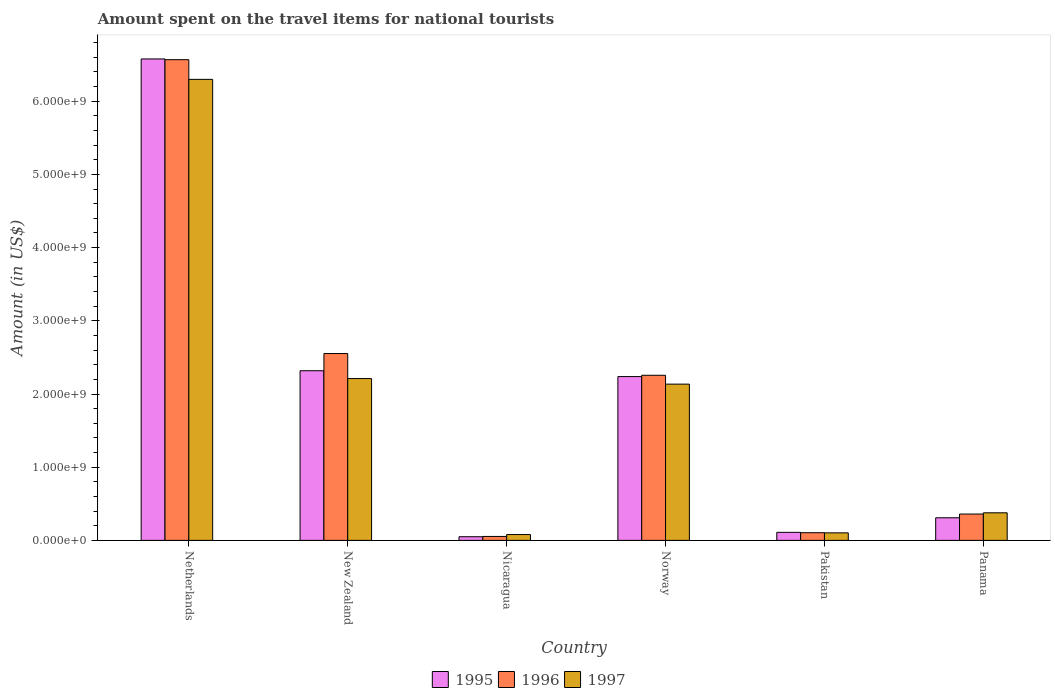Are the number of bars per tick equal to the number of legend labels?
Your answer should be compact. Yes. Are the number of bars on each tick of the X-axis equal?
Your answer should be very brief. Yes. What is the label of the 3rd group of bars from the left?
Provide a succinct answer. Nicaragua. What is the amount spent on the travel items for national tourists in 1995 in Nicaragua?
Provide a short and direct response. 5.00e+07. Across all countries, what is the maximum amount spent on the travel items for national tourists in 1997?
Offer a terse response. 6.30e+09. Across all countries, what is the minimum amount spent on the travel items for national tourists in 1995?
Make the answer very short. 5.00e+07. In which country was the amount spent on the travel items for national tourists in 1997 minimum?
Provide a short and direct response. Nicaragua. What is the total amount spent on the travel items for national tourists in 1996 in the graph?
Your response must be concise. 1.19e+1. What is the difference between the amount spent on the travel items for national tourists in 1996 in Nicaragua and that in Panama?
Make the answer very short. -3.06e+08. What is the difference between the amount spent on the travel items for national tourists in 1997 in Nicaragua and the amount spent on the travel items for national tourists in 1996 in Pakistan?
Ensure brevity in your answer.  -2.50e+07. What is the average amount spent on the travel items for national tourists in 1997 per country?
Ensure brevity in your answer.  1.87e+09. What is the difference between the amount spent on the travel items for national tourists of/in 1997 and amount spent on the travel items for national tourists of/in 1995 in New Zealand?
Keep it short and to the point. -1.07e+08. In how many countries, is the amount spent on the travel items for national tourists in 1997 greater than 4200000000 US$?
Offer a terse response. 1. What is the ratio of the amount spent on the travel items for national tourists in 1997 in New Zealand to that in Norway?
Keep it short and to the point. 1.04. Is the amount spent on the travel items for national tourists in 1997 in New Zealand less than that in Norway?
Your answer should be compact. No. Is the difference between the amount spent on the travel items for national tourists in 1997 in New Zealand and Panama greater than the difference between the amount spent on the travel items for national tourists in 1995 in New Zealand and Panama?
Give a very brief answer. No. What is the difference between the highest and the second highest amount spent on the travel items for national tourists in 1997?
Provide a short and direct response. 4.16e+09. What is the difference between the highest and the lowest amount spent on the travel items for national tourists in 1996?
Keep it short and to the point. 6.51e+09. Is it the case that in every country, the sum of the amount spent on the travel items for national tourists in 1996 and amount spent on the travel items for national tourists in 1995 is greater than the amount spent on the travel items for national tourists in 1997?
Make the answer very short. Yes. How many bars are there?
Your answer should be compact. 18. Are all the bars in the graph horizontal?
Provide a succinct answer. No. How many countries are there in the graph?
Offer a very short reply. 6. What is the difference between two consecutive major ticks on the Y-axis?
Keep it short and to the point. 1.00e+09. Where does the legend appear in the graph?
Offer a very short reply. Bottom center. How many legend labels are there?
Provide a succinct answer. 3. How are the legend labels stacked?
Offer a terse response. Horizontal. What is the title of the graph?
Make the answer very short. Amount spent on the travel items for national tourists. What is the Amount (in US$) in 1995 in Netherlands?
Your response must be concise. 6.58e+09. What is the Amount (in US$) in 1996 in Netherlands?
Keep it short and to the point. 6.57e+09. What is the Amount (in US$) of 1997 in Netherlands?
Provide a short and direct response. 6.30e+09. What is the Amount (in US$) of 1995 in New Zealand?
Provide a succinct answer. 2.32e+09. What is the Amount (in US$) in 1996 in New Zealand?
Ensure brevity in your answer.  2.55e+09. What is the Amount (in US$) in 1997 in New Zealand?
Keep it short and to the point. 2.21e+09. What is the Amount (in US$) of 1996 in Nicaragua?
Your response must be concise. 5.40e+07. What is the Amount (in US$) of 1997 in Nicaragua?
Ensure brevity in your answer.  8.00e+07. What is the Amount (in US$) of 1995 in Norway?
Your answer should be very brief. 2.24e+09. What is the Amount (in US$) of 1996 in Norway?
Offer a very short reply. 2.26e+09. What is the Amount (in US$) of 1997 in Norway?
Your answer should be very brief. 2.14e+09. What is the Amount (in US$) of 1995 in Pakistan?
Make the answer very short. 1.10e+08. What is the Amount (in US$) of 1996 in Pakistan?
Keep it short and to the point. 1.05e+08. What is the Amount (in US$) in 1997 in Pakistan?
Ensure brevity in your answer.  1.03e+08. What is the Amount (in US$) of 1995 in Panama?
Offer a terse response. 3.09e+08. What is the Amount (in US$) in 1996 in Panama?
Your answer should be very brief. 3.60e+08. What is the Amount (in US$) in 1997 in Panama?
Provide a succinct answer. 3.77e+08. Across all countries, what is the maximum Amount (in US$) of 1995?
Ensure brevity in your answer.  6.58e+09. Across all countries, what is the maximum Amount (in US$) of 1996?
Offer a very short reply. 6.57e+09. Across all countries, what is the maximum Amount (in US$) in 1997?
Provide a succinct answer. 6.30e+09. Across all countries, what is the minimum Amount (in US$) of 1995?
Offer a very short reply. 5.00e+07. Across all countries, what is the minimum Amount (in US$) of 1996?
Provide a short and direct response. 5.40e+07. Across all countries, what is the minimum Amount (in US$) in 1997?
Give a very brief answer. 8.00e+07. What is the total Amount (in US$) in 1995 in the graph?
Your answer should be compact. 1.16e+1. What is the total Amount (in US$) of 1996 in the graph?
Provide a short and direct response. 1.19e+1. What is the total Amount (in US$) of 1997 in the graph?
Give a very brief answer. 1.12e+1. What is the difference between the Amount (in US$) in 1995 in Netherlands and that in New Zealand?
Your answer should be very brief. 4.26e+09. What is the difference between the Amount (in US$) of 1996 in Netherlands and that in New Zealand?
Make the answer very short. 4.02e+09. What is the difference between the Amount (in US$) of 1997 in Netherlands and that in New Zealand?
Provide a short and direct response. 4.09e+09. What is the difference between the Amount (in US$) in 1995 in Netherlands and that in Nicaragua?
Make the answer very short. 6.53e+09. What is the difference between the Amount (in US$) of 1996 in Netherlands and that in Nicaragua?
Offer a terse response. 6.51e+09. What is the difference between the Amount (in US$) of 1997 in Netherlands and that in Nicaragua?
Offer a very short reply. 6.22e+09. What is the difference between the Amount (in US$) of 1995 in Netherlands and that in Norway?
Your answer should be very brief. 4.34e+09. What is the difference between the Amount (in US$) in 1996 in Netherlands and that in Norway?
Provide a short and direct response. 4.31e+09. What is the difference between the Amount (in US$) of 1997 in Netherlands and that in Norway?
Keep it short and to the point. 4.16e+09. What is the difference between the Amount (in US$) in 1995 in Netherlands and that in Pakistan?
Your answer should be compact. 6.47e+09. What is the difference between the Amount (in US$) of 1996 in Netherlands and that in Pakistan?
Give a very brief answer. 6.46e+09. What is the difference between the Amount (in US$) of 1997 in Netherlands and that in Pakistan?
Ensure brevity in your answer.  6.20e+09. What is the difference between the Amount (in US$) of 1995 in Netherlands and that in Panama?
Your response must be concise. 6.27e+09. What is the difference between the Amount (in US$) in 1996 in Netherlands and that in Panama?
Keep it short and to the point. 6.21e+09. What is the difference between the Amount (in US$) in 1997 in Netherlands and that in Panama?
Give a very brief answer. 5.92e+09. What is the difference between the Amount (in US$) in 1995 in New Zealand and that in Nicaragua?
Offer a terse response. 2.27e+09. What is the difference between the Amount (in US$) in 1996 in New Zealand and that in Nicaragua?
Provide a succinct answer. 2.50e+09. What is the difference between the Amount (in US$) of 1997 in New Zealand and that in Nicaragua?
Your answer should be very brief. 2.13e+09. What is the difference between the Amount (in US$) in 1995 in New Zealand and that in Norway?
Offer a terse response. 8.00e+07. What is the difference between the Amount (in US$) of 1996 in New Zealand and that in Norway?
Make the answer very short. 2.97e+08. What is the difference between the Amount (in US$) of 1997 in New Zealand and that in Norway?
Offer a very short reply. 7.60e+07. What is the difference between the Amount (in US$) in 1995 in New Zealand and that in Pakistan?
Make the answer very short. 2.21e+09. What is the difference between the Amount (in US$) of 1996 in New Zealand and that in Pakistan?
Provide a short and direct response. 2.45e+09. What is the difference between the Amount (in US$) of 1997 in New Zealand and that in Pakistan?
Offer a terse response. 2.11e+09. What is the difference between the Amount (in US$) in 1995 in New Zealand and that in Panama?
Keep it short and to the point. 2.01e+09. What is the difference between the Amount (in US$) in 1996 in New Zealand and that in Panama?
Provide a short and direct response. 2.19e+09. What is the difference between the Amount (in US$) in 1997 in New Zealand and that in Panama?
Your answer should be very brief. 1.83e+09. What is the difference between the Amount (in US$) of 1995 in Nicaragua and that in Norway?
Offer a very short reply. -2.19e+09. What is the difference between the Amount (in US$) in 1996 in Nicaragua and that in Norway?
Provide a succinct answer. -2.20e+09. What is the difference between the Amount (in US$) in 1997 in Nicaragua and that in Norway?
Your answer should be very brief. -2.06e+09. What is the difference between the Amount (in US$) of 1995 in Nicaragua and that in Pakistan?
Provide a short and direct response. -6.00e+07. What is the difference between the Amount (in US$) of 1996 in Nicaragua and that in Pakistan?
Keep it short and to the point. -5.10e+07. What is the difference between the Amount (in US$) in 1997 in Nicaragua and that in Pakistan?
Offer a very short reply. -2.30e+07. What is the difference between the Amount (in US$) in 1995 in Nicaragua and that in Panama?
Ensure brevity in your answer.  -2.59e+08. What is the difference between the Amount (in US$) of 1996 in Nicaragua and that in Panama?
Provide a short and direct response. -3.06e+08. What is the difference between the Amount (in US$) of 1997 in Nicaragua and that in Panama?
Offer a very short reply. -2.97e+08. What is the difference between the Amount (in US$) in 1995 in Norway and that in Pakistan?
Offer a terse response. 2.13e+09. What is the difference between the Amount (in US$) of 1996 in Norway and that in Pakistan?
Keep it short and to the point. 2.15e+09. What is the difference between the Amount (in US$) in 1997 in Norway and that in Pakistan?
Make the answer very short. 2.03e+09. What is the difference between the Amount (in US$) of 1995 in Norway and that in Panama?
Your answer should be very brief. 1.93e+09. What is the difference between the Amount (in US$) of 1996 in Norway and that in Panama?
Your answer should be very brief. 1.90e+09. What is the difference between the Amount (in US$) in 1997 in Norway and that in Panama?
Your response must be concise. 1.76e+09. What is the difference between the Amount (in US$) in 1995 in Pakistan and that in Panama?
Your answer should be very brief. -1.99e+08. What is the difference between the Amount (in US$) of 1996 in Pakistan and that in Panama?
Make the answer very short. -2.55e+08. What is the difference between the Amount (in US$) of 1997 in Pakistan and that in Panama?
Give a very brief answer. -2.74e+08. What is the difference between the Amount (in US$) in 1995 in Netherlands and the Amount (in US$) in 1996 in New Zealand?
Keep it short and to the point. 4.02e+09. What is the difference between the Amount (in US$) in 1995 in Netherlands and the Amount (in US$) in 1997 in New Zealand?
Your answer should be very brief. 4.37e+09. What is the difference between the Amount (in US$) in 1996 in Netherlands and the Amount (in US$) in 1997 in New Zealand?
Offer a terse response. 4.36e+09. What is the difference between the Amount (in US$) in 1995 in Netherlands and the Amount (in US$) in 1996 in Nicaragua?
Your answer should be compact. 6.52e+09. What is the difference between the Amount (in US$) in 1995 in Netherlands and the Amount (in US$) in 1997 in Nicaragua?
Provide a succinct answer. 6.50e+09. What is the difference between the Amount (in US$) of 1996 in Netherlands and the Amount (in US$) of 1997 in Nicaragua?
Keep it short and to the point. 6.49e+09. What is the difference between the Amount (in US$) of 1995 in Netherlands and the Amount (in US$) of 1996 in Norway?
Offer a terse response. 4.32e+09. What is the difference between the Amount (in US$) of 1995 in Netherlands and the Amount (in US$) of 1997 in Norway?
Your answer should be compact. 4.44e+09. What is the difference between the Amount (in US$) of 1996 in Netherlands and the Amount (in US$) of 1997 in Norway?
Offer a very short reply. 4.43e+09. What is the difference between the Amount (in US$) of 1995 in Netherlands and the Amount (in US$) of 1996 in Pakistan?
Your response must be concise. 6.47e+09. What is the difference between the Amount (in US$) in 1995 in Netherlands and the Amount (in US$) in 1997 in Pakistan?
Ensure brevity in your answer.  6.48e+09. What is the difference between the Amount (in US$) of 1996 in Netherlands and the Amount (in US$) of 1997 in Pakistan?
Ensure brevity in your answer.  6.46e+09. What is the difference between the Amount (in US$) in 1995 in Netherlands and the Amount (in US$) in 1996 in Panama?
Provide a succinct answer. 6.22e+09. What is the difference between the Amount (in US$) of 1995 in Netherlands and the Amount (in US$) of 1997 in Panama?
Offer a very short reply. 6.20e+09. What is the difference between the Amount (in US$) in 1996 in Netherlands and the Amount (in US$) in 1997 in Panama?
Give a very brief answer. 6.19e+09. What is the difference between the Amount (in US$) in 1995 in New Zealand and the Amount (in US$) in 1996 in Nicaragua?
Give a very brief answer. 2.26e+09. What is the difference between the Amount (in US$) in 1995 in New Zealand and the Amount (in US$) in 1997 in Nicaragua?
Your answer should be compact. 2.24e+09. What is the difference between the Amount (in US$) of 1996 in New Zealand and the Amount (in US$) of 1997 in Nicaragua?
Make the answer very short. 2.47e+09. What is the difference between the Amount (in US$) in 1995 in New Zealand and the Amount (in US$) in 1996 in Norway?
Make the answer very short. 6.20e+07. What is the difference between the Amount (in US$) of 1995 in New Zealand and the Amount (in US$) of 1997 in Norway?
Your answer should be compact. 1.83e+08. What is the difference between the Amount (in US$) of 1996 in New Zealand and the Amount (in US$) of 1997 in Norway?
Provide a short and direct response. 4.18e+08. What is the difference between the Amount (in US$) in 1995 in New Zealand and the Amount (in US$) in 1996 in Pakistan?
Offer a terse response. 2.21e+09. What is the difference between the Amount (in US$) in 1995 in New Zealand and the Amount (in US$) in 1997 in Pakistan?
Offer a very short reply. 2.22e+09. What is the difference between the Amount (in US$) in 1996 in New Zealand and the Amount (in US$) in 1997 in Pakistan?
Your response must be concise. 2.45e+09. What is the difference between the Amount (in US$) in 1995 in New Zealand and the Amount (in US$) in 1996 in Panama?
Your response must be concise. 1.96e+09. What is the difference between the Amount (in US$) in 1995 in New Zealand and the Amount (in US$) in 1997 in Panama?
Offer a terse response. 1.94e+09. What is the difference between the Amount (in US$) in 1996 in New Zealand and the Amount (in US$) in 1997 in Panama?
Keep it short and to the point. 2.18e+09. What is the difference between the Amount (in US$) of 1995 in Nicaragua and the Amount (in US$) of 1996 in Norway?
Provide a succinct answer. -2.21e+09. What is the difference between the Amount (in US$) in 1995 in Nicaragua and the Amount (in US$) in 1997 in Norway?
Give a very brief answer. -2.08e+09. What is the difference between the Amount (in US$) in 1996 in Nicaragua and the Amount (in US$) in 1997 in Norway?
Give a very brief answer. -2.08e+09. What is the difference between the Amount (in US$) in 1995 in Nicaragua and the Amount (in US$) in 1996 in Pakistan?
Your response must be concise. -5.50e+07. What is the difference between the Amount (in US$) in 1995 in Nicaragua and the Amount (in US$) in 1997 in Pakistan?
Your answer should be very brief. -5.30e+07. What is the difference between the Amount (in US$) of 1996 in Nicaragua and the Amount (in US$) of 1997 in Pakistan?
Give a very brief answer. -4.90e+07. What is the difference between the Amount (in US$) of 1995 in Nicaragua and the Amount (in US$) of 1996 in Panama?
Your response must be concise. -3.10e+08. What is the difference between the Amount (in US$) of 1995 in Nicaragua and the Amount (in US$) of 1997 in Panama?
Keep it short and to the point. -3.27e+08. What is the difference between the Amount (in US$) in 1996 in Nicaragua and the Amount (in US$) in 1997 in Panama?
Ensure brevity in your answer.  -3.23e+08. What is the difference between the Amount (in US$) in 1995 in Norway and the Amount (in US$) in 1996 in Pakistan?
Your answer should be very brief. 2.13e+09. What is the difference between the Amount (in US$) of 1995 in Norway and the Amount (in US$) of 1997 in Pakistan?
Provide a succinct answer. 2.14e+09. What is the difference between the Amount (in US$) in 1996 in Norway and the Amount (in US$) in 1997 in Pakistan?
Ensure brevity in your answer.  2.15e+09. What is the difference between the Amount (in US$) in 1995 in Norway and the Amount (in US$) in 1996 in Panama?
Provide a short and direct response. 1.88e+09. What is the difference between the Amount (in US$) of 1995 in Norway and the Amount (in US$) of 1997 in Panama?
Your answer should be compact. 1.86e+09. What is the difference between the Amount (in US$) of 1996 in Norway and the Amount (in US$) of 1997 in Panama?
Ensure brevity in your answer.  1.88e+09. What is the difference between the Amount (in US$) of 1995 in Pakistan and the Amount (in US$) of 1996 in Panama?
Your response must be concise. -2.50e+08. What is the difference between the Amount (in US$) of 1995 in Pakistan and the Amount (in US$) of 1997 in Panama?
Your answer should be very brief. -2.67e+08. What is the difference between the Amount (in US$) in 1996 in Pakistan and the Amount (in US$) in 1997 in Panama?
Make the answer very short. -2.72e+08. What is the average Amount (in US$) in 1995 per country?
Provide a succinct answer. 1.93e+09. What is the average Amount (in US$) of 1996 per country?
Make the answer very short. 1.98e+09. What is the average Amount (in US$) in 1997 per country?
Your answer should be compact. 1.87e+09. What is the difference between the Amount (in US$) in 1995 and Amount (in US$) in 1996 in Netherlands?
Give a very brief answer. 1.00e+07. What is the difference between the Amount (in US$) of 1995 and Amount (in US$) of 1997 in Netherlands?
Give a very brief answer. 2.79e+08. What is the difference between the Amount (in US$) of 1996 and Amount (in US$) of 1997 in Netherlands?
Give a very brief answer. 2.69e+08. What is the difference between the Amount (in US$) in 1995 and Amount (in US$) in 1996 in New Zealand?
Ensure brevity in your answer.  -2.35e+08. What is the difference between the Amount (in US$) of 1995 and Amount (in US$) of 1997 in New Zealand?
Your answer should be compact. 1.07e+08. What is the difference between the Amount (in US$) of 1996 and Amount (in US$) of 1997 in New Zealand?
Make the answer very short. 3.42e+08. What is the difference between the Amount (in US$) of 1995 and Amount (in US$) of 1997 in Nicaragua?
Give a very brief answer. -3.00e+07. What is the difference between the Amount (in US$) of 1996 and Amount (in US$) of 1997 in Nicaragua?
Offer a very short reply. -2.60e+07. What is the difference between the Amount (in US$) in 1995 and Amount (in US$) in 1996 in Norway?
Give a very brief answer. -1.80e+07. What is the difference between the Amount (in US$) of 1995 and Amount (in US$) of 1997 in Norway?
Provide a short and direct response. 1.03e+08. What is the difference between the Amount (in US$) of 1996 and Amount (in US$) of 1997 in Norway?
Ensure brevity in your answer.  1.21e+08. What is the difference between the Amount (in US$) of 1995 and Amount (in US$) of 1997 in Pakistan?
Provide a succinct answer. 7.00e+06. What is the difference between the Amount (in US$) in 1996 and Amount (in US$) in 1997 in Pakistan?
Provide a short and direct response. 2.00e+06. What is the difference between the Amount (in US$) of 1995 and Amount (in US$) of 1996 in Panama?
Give a very brief answer. -5.10e+07. What is the difference between the Amount (in US$) of 1995 and Amount (in US$) of 1997 in Panama?
Offer a very short reply. -6.80e+07. What is the difference between the Amount (in US$) in 1996 and Amount (in US$) in 1997 in Panama?
Make the answer very short. -1.70e+07. What is the ratio of the Amount (in US$) in 1995 in Netherlands to that in New Zealand?
Give a very brief answer. 2.84. What is the ratio of the Amount (in US$) of 1996 in Netherlands to that in New Zealand?
Offer a terse response. 2.57. What is the ratio of the Amount (in US$) of 1997 in Netherlands to that in New Zealand?
Make the answer very short. 2.85. What is the ratio of the Amount (in US$) of 1995 in Netherlands to that in Nicaragua?
Provide a short and direct response. 131.56. What is the ratio of the Amount (in US$) of 1996 in Netherlands to that in Nicaragua?
Give a very brief answer. 121.63. What is the ratio of the Amount (in US$) of 1997 in Netherlands to that in Nicaragua?
Offer a very short reply. 78.74. What is the ratio of the Amount (in US$) in 1995 in Netherlands to that in Norway?
Offer a very short reply. 2.94. What is the ratio of the Amount (in US$) of 1996 in Netherlands to that in Norway?
Offer a very short reply. 2.91. What is the ratio of the Amount (in US$) in 1997 in Netherlands to that in Norway?
Offer a terse response. 2.95. What is the ratio of the Amount (in US$) in 1995 in Netherlands to that in Pakistan?
Make the answer very short. 59.8. What is the ratio of the Amount (in US$) of 1996 in Netherlands to that in Pakistan?
Provide a short and direct response. 62.55. What is the ratio of the Amount (in US$) of 1997 in Netherlands to that in Pakistan?
Give a very brief answer. 61.16. What is the ratio of the Amount (in US$) of 1995 in Netherlands to that in Panama?
Offer a terse response. 21.29. What is the ratio of the Amount (in US$) of 1996 in Netherlands to that in Panama?
Your answer should be very brief. 18.24. What is the ratio of the Amount (in US$) of 1997 in Netherlands to that in Panama?
Your answer should be compact. 16.71. What is the ratio of the Amount (in US$) of 1995 in New Zealand to that in Nicaragua?
Offer a very short reply. 46.36. What is the ratio of the Amount (in US$) in 1996 in New Zealand to that in Nicaragua?
Make the answer very short. 47.28. What is the ratio of the Amount (in US$) of 1997 in New Zealand to that in Nicaragua?
Your answer should be very brief. 27.64. What is the ratio of the Amount (in US$) of 1995 in New Zealand to that in Norway?
Make the answer very short. 1.04. What is the ratio of the Amount (in US$) of 1996 in New Zealand to that in Norway?
Give a very brief answer. 1.13. What is the ratio of the Amount (in US$) of 1997 in New Zealand to that in Norway?
Ensure brevity in your answer.  1.04. What is the ratio of the Amount (in US$) in 1995 in New Zealand to that in Pakistan?
Provide a short and direct response. 21.07. What is the ratio of the Amount (in US$) in 1996 in New Zealand to that in Pakistan?
Ensure brevity in your answer.  24.31. What is the ratio of the Amount (in US$) of 1997 in New Zealand to that in Pakistan?
Offer a very short reply. 21.47. What is the ratio of the Amount (in US$) in 1995 in New Zealand to that in Panama?
Your response must be concise. 7.5. What is the ratio of the Amount (in US$) in 1996 in New Zealand to that in Panama?
Ensure brevity in your answer.  7.09. What is the ratio of the Amount (in US$) in 1997 in New Zealand to that in Panama?
Offer a terse response. 5.86. What is the ratio of the Amount (in US$) in 1995 in Nicaragua to that in Norway?
Keep it short and to the point. 0.02. What is the ratio of the Amount (in US$) in 1996 in Nicaragua to that in Norway?
Your response must be concise. 0.02. What is the ratio of the Amount (in US$) of 1997 in Nicaragua to that in Norway?
Make the answer very short. 0.04. What is the ratio of the Amount (in US$) in 1995 in Nicaragua to that in Pakistan?
Offer a terse response. 0.45. What is the ratio of the Amount (in US$) of 1996 in Nicaragua to that in Pakistan?
Give a very brief answer. 0.51. What is the ratio of the Amount (in US$) of 1997 in Nicaragua to that in Pakistan?
Make the answer very short. 0.78. What is the ratio of the Amount (in US$) of 1995 in Nicaragua to that in Panama?
Your response must be concise. 0.16. What is the ratio of the Amount (in US$) in 1996 in Nicaragua to that in Panama?
Offer a very short reply. 0.15. What is the ratio of the Amount (in US$) in 1997 in Nicaragua to that in Panama?
Make the answer very short. 0.21. What is the ratio of the Amount (in US$) in 1995 in Norway to that in Pakistan?
Your response must be concise. 20.35. What is the ratio of the Amount (in US$) in 1996 in Norway to that in Pakistan?
Your answer should be compact. 21.49. What is the ratio of the Amount (in US$) of 1997 in Norway to that in Pakistan?
Your response must be concise. 20.73. What is the ratio of the Amount (in US$) in 1995 in Norway to that in Panama?
Provide a short and direct response. 7.24. What is the ratio of the Amount (in US$) of 1996 in Norway to that in Panama?
Keep it short and to the point. 6.27. What is the ratio of the Amount (in US$) in 1997 in Norway to that in Panama?
Provide a short and direct response. 5.66. What is the ratio of the Amount (in US$) of 1995 in Pakistan to that in Panama?
Ensure brevity in your answer.  0.36. What is the ratio of the Amount (in US$) of 1996 in Pakistan to that in Panama?
Keep it short and to the point. 0.29. What is the ratio of the Amount (in US$) in 1997 in Pakistan to that in Panama?
Your response must be concise. 0.27. What is the difference between the highest and the second highest Amount (in US$) in 1995?
Offer a very short reply. 4.26e+09. What is the difference between the highest and the second highest Amount (in US$) in 1996?
Keep it short and to the point. 4.02e+09. What is the difference between the highest and the second highest Amount (in US$) of 1997?
Ensure brevity in your answer.  4.09e+09. What is the difference between the highest and the lowest Amount (in US$) of 1995?
Provide a short and direct response. 6.53e+09. What is the difference between the highest and the lowest Amount (in US$) in 1996?
Your answer should be very brief. 6.51e+09. What is the difference between the highest and the lowest Amount (in US$) in 1997?
Offer a terse response. 6.22e+09. 